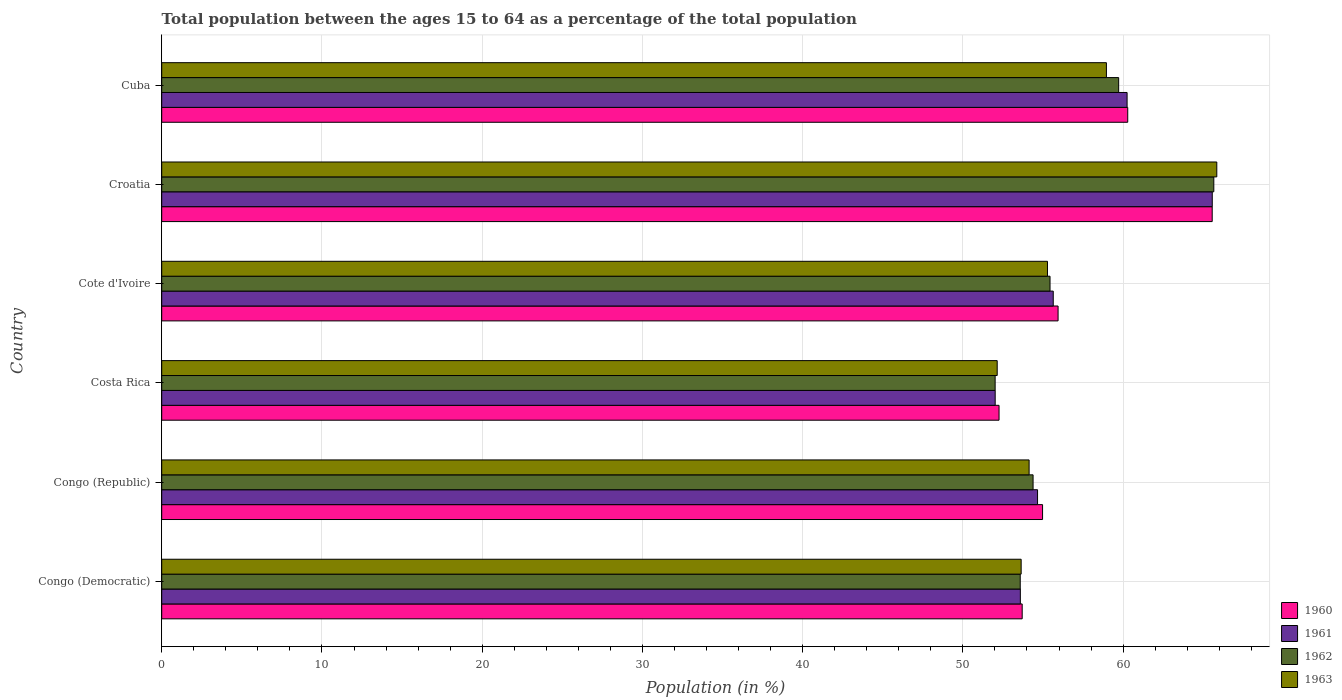Are the number of bars per tick equal to the number of legend labels?
Your answer should be very brief. Yes. How many bars are there on the 6th tick from the top?
Ensure brevity in your answer.  4. What is the label of the 6th group of bars from the top?
Offer a terse response. Congo (Democratic). In how many cases, is the number of bars for a given country not equal to the number of legend labels?
Keep it short and to the point. 0. What is the percentage of the population ages 15 to 64 in 1962 in Cote d'Ivoire?
Offer a very short reply. 55.44. Across all countries, what is the maximum percentage of the population ages 15 to 64 in 1961?
Provide a succinct answer. 65.56. Across all countries, what is the minimum percentage of the population ages 15 to 64 in 1963?
Your answer should be compact. 52.14. In which country was the percentage of the population ages 15 to 64 in 1960 maximum?
Provide a short and direct response. Croatia. What is the total percentage of the population ages 15 to 64 in 1961 in the graph?
Ensure brevity in your answer.  341.71. What is the difference between the percentage of the population ages 15 to 64 in 1962 in Congo (Democratic) and that in Cuba?
Make the answer very short. -6.14. What is the difference between the percentage of the population ages 15 to 64 in 1962 in Congo (Democratic) and the percentage of the population ages 15 to 64 in 1961 in Cuba?
Provide a succinct answer. -6.67. What is the average percentage of the population ages 15 to 64 in 1960 per country?
Your answer should be very brief. 57.12. What is the difference between the percentage of the population ages 15 to 64 in 1963 and percentage of the population ages 15 to 64 in 1961 in Cote d'Ivoire?
Offer a very short reply. -0.36. In how many countries, is the percentage of the population ages 15 to 64 in 1962 greater than 48 ?
Provide a short and direct response. 6. What is the ratio of the percentage of the population ages 15 to 64 in 1963 in Cote d'Ivoire to that in Croatia?
Ensure brevity in your answer.  0.84. Is the percentage of the population ages 15 to 64 in 1960 in Congo (Democratic) less than that in Croatia?
Keep it short and to the point. Yes. What is the difference between the highest and the second highest percentage of the population ages 15 to 64 in 1961?
Offer a terse response. 5.32. What is the difference between the highest and the lowest percentage of the population ages 15 to 64 in 1961?
Offer a terse response. 13.55. In how many countries, is the percentage of the population ages 15 to 64 in 1962 greater than the average percentage of the population ages 15 to 64 in 1962 taken over all countries?
Give a very brief answer. 2. What does the 1st bar from the bottom in Cote d'Ivoire represents?
Keep it short and to the point. 1960. How many bars are there?
Ensure brevity in your answer.  24. Does the graph contain any zero values?
Keep it short and to the point. No. Does the graph contain grids?
Keep it short and to the point. Yes. Where does the legend appear in the graph?
Provide a succinct answer. Bottom right. How are the legend labels stacked?
Your answer should be very brief. Vertical. What is the title of the graph?
Your answer should be compact. Total population between the ages 15 to 64 as a percentage of the total population. What is the label or title of the X-axis?
Your response must be concise. Population (in %). What is the Population (in %) in 1960 in Congo (Democratic)?
Make the answer very short. 53.7. What is the Population (in %) in 1961 in Congo (Democratic)?
Give a very brief answer. 53.59. What is the Population (in %) of 1962 in Congo (Democratic)?
Your response must be concise. 53.58. What is the Population (in %) of 1963 in Congo (Democratic)?
Make the answer very short. 53.64. What is the Population (in %) of 1960 in Congo (Republic)?
Give a very brief answer. 54.97. What is the Population (in %) in 1961 in Congo (Republic)?
Keep it short and to the point. 54.66. What is the Population (in %) in 1962 in Congo (Republic)?
Provide a short and direct response. 54.38. What is the Population (in %) in 1963 in Congo (Republic)?
Offer a very short reply. 54.13. What is the Population (in %) in 1960 in Costa Rica?
Your response must be concise. 52.26. What is the Population (in %) of 1961 in Costa Rica?
Your response must be concise. 52.02. What is the Population (in %) in 1962 in Costa Rica?
Your answer should be very brief. 52.01. What is the Population (in %) in 1963 in Costa Rica?
Keep it short and to the point. 52.14. What is the Population (in %) in 1960 in Cote d'Ivoire?
Your answer should be compact. 55.94. What is the Population (in %) in 1961 in Cote d'Ivoire?
Ensure brevity in your answer.  55.64. What is the Population (in %) in 1962 in Cote d'Ivoire?
Your answer should be very brief. 55.44. What is the Population (in %) of 1963 in Cote d'Ivoire?
Offer a terse response. 55.28. What is the Population (in %) of 1960 in Croatia?
Provide a succinct answer. 65.56. What is the Population (in %) of 1961 in Croatia?
Offer a very short reply. 65.56. What is the Population (in %) in 1962 in Croatia?
Offer a terse response. 65.66. What is the Population (in %) in 1963 in Croatia?
Your response must be concise. 65.85. What is the Population (in %) in 1960 in Cuba?
Keep it short and to the point. 60.29. What is the Population (in %) in 1961 in Cuba?
Your response must be concise. 60.25. What is the Population (in %) of 1962 in Cuba?
Your response must be concise. 59.72. What is the Population (in %) in 1963 in Cuba?
Make the answer very short. 58.96. Across all countries, what is the maximum Population (in %) in 1960?
Your response must be concise. 65.56. Across all countries, what is the maximum Population (in %) of 1961?
Keep it short and to the point. 65.56. Across all countries, what is the maximum Population (in %) in 1962?
Provide a short and direct response. 65.66. Across all countries, what is the maximum Population (in %) in 1963?
Your answer should be compact. 65.85. Across all countries, what is the minimum Population (in %) of 1960?
Provide a succinct answer. 52.26. Across all countries, what is the minimum Population (in %) of 1961?
Your response must be concise. 52.02. Across all countries, what is the minimum Population (in %) of 1962?
Ensure brevity in your answer.  52.01. Across all countries, what is the minimum Population (in %) of 1963?
Your answer should be very brief. 52.14. What is the total Population (in %) in 1960 in the graph?
Offer a terse response. 342.72. What is the total Population (in %) in 1961 in the graph?
Your answer should be compact. 341.71. What is the total Population (in %) of 1962 in the graph?
Give a very brief answer. 340.79. What is the total Population (in %) of 1963 in the graph?
Ensure brevity in your answer.  340. What is the difference between the Population (in %) of 1960 in Congo (Democratic) and that in Congo (Republic)?
Your answer should be compact. -1.27. What is the difference between the Population (in %) of 1961 in Congo (Democratic) and that in Congo (Republic)?
Make the answer very short. -1.07. What is the difference between the Population (in %) of 1962 in Congo (Democratic) and that in Congo (Republic)?
Keep it short and to the point. -0.8. What is the difference between the Population (in %) in 1963 in Congo (Democratic) and that in Congo (Republic)?
Make the answer very short. -0.5. What is the difference between the Population (in %) in 1960 in Congo (Democratic) and that in Costa Rica?
Give a very brief answer. 1.44. What is the difference between the Population (in %) of 1961 in Congo (Democratic) and that in Costa Rica?
Give a very brief answer. 1.57. What is the difference between the Population (in %) of 1962 in Congo (Democratic) and that in Costa Rica?
Offer a very short reply. 1.57. What is the difference between the Population (in %) of 1963 in Congo (Democratic) and that in Costa Rica?
Your answer should be compact. 1.5. What is the difference between the Population (in %) of 1960 in Congo (Democratic) and that in Cote d'Ivoire?
Offer a very short reply. -2.24. What is the difference between the Population (in %) in 1961 in Congo (Democratic) and that in Cote d'Ivoire?
Keep it short and to the point. -2.05. What is the difference between the Population (in %) in 1962 in Congo (Democratic) and that in Cote d'Ivoire?
Give a very brief answer. -1.86. What is the difference between the Population (in %) of 1963 in Congo (Democratic) and that in Cote d'Ivoire?
Provide a short and direct response. -1.64. What is the difference between the Population (in %) of 1960 in Congo (Democratic) and that in Croatia?
Offer a very short reply. -11.86. What is the difference between the Population (in %) in 1961 in Congo (Democratic) and that in Croatia?
Your response must be concise. -11.98. What is the difference between the Population (in %) in 1962 in Congo (Democratic) and that in Croatia?
Offer a very short reply. -12.08. What is the difference between the Population (in %) in 1963 in Congo (Democratic) and that in Croatia?
Offer a very short reply. -12.21. What is the difference between the Population (in %) in 1960 in Congo (Democratic) and that in Cuba?
Offer a very short reply. -6.59. What is the difference between the Population (in %) of 1961 in Congo (Democratic) and that in Cuba?
Provide a short and direct response. -6.66. What is the difference between the Population (in %) of 1962 in Congo (Democratic) and that in Cuba?
Offer a terse response. -6.14. What is the difference between the Population (in %) in 1963 in Congo (Democratic) and that in Cuba?
Provide a succinct answer. -5.32. What is the difference between the Population (in %) of 1960 in Congo (Republic) and that in Costa Rica?
Offer a terse response. 2.72. What is the difference between the Population (in %) of 1961 in Congo (Republic) and that in Costa Rica?
Give a very brief answer. 2.64. What is the difference between the Population (in %) of 1962 in Congo (Republic) and that in Costa Rica?
Offer a very short reply. 2.37. What is the difference between the Population (in %) of 1963 in Congo (Republic) and that in Costa Rica?
Offer a very short reply. 1.99. What is the difference between the Population (in %) in 1960 in Congo (Republic) and that in Cote d'Ivoire?
Your answer should be compact. -0.97. What is the difference between the Population (in %) in 1961 in Congo (Republic) and that in Cote d'Ivoire?
Your answer should be very brief. -0.98. What is the difference between the Population (in %) of 1962 in Congo (Republic) and that in Cote d'Ivoire?
Your answer should be compact. -1.06. What is the difference between the Population (in %) in 1963 in Congo (Republic) and that in Cote d'Ivoire?
Make the answer very short. -1.15. What is the difference between the Population (in %) of 1960 in Congo (Republic) and that in Croatia?
Keep it short and to the point. -10.59. What is the difference between the Population (in %) in 1961 in Congo (Republic) and that in Croatia?
Make the answer very short. -10.9. What is the difference between the Population (in %) in 1962 in Congo (Republic) and that in Croatia?
Your answer should be compact. -11.28. What is the difference between the Population (in %) in 1963 in Congo (Republic) and that in Croatia?
Your response must be concise. -11.71. What is the difference between the Population (in %) of 1960 in Congo (Republic) and that in Cuba?
Provide a short and direct response. -5.32. What is the difference between the Population (in %) in 1961 in Congo (Republic) and that in Cuba?
Keep it short and to the point. -5.59. What is the difference between the Population (in %) in 1962 in Congo (Republic) and that in Cuba?
Offer a very short reply. -5.34. What is the difference between the Population (in %) of 1963 in Congo (Republic) and that in Cuba?
Offer a very short reply. -4.83. What is the difference between the Population (in %) in 1960 in Costa Rica and that in Cote d'Ivoire?
Give a very brief answer. -3.68. What is the difference between the Population (in %) in 1961 in Costa Rica and that in Cote d'Ivoire?
Give a very brief answer. -3.62. What is the difference between the Population (in %) of 1962 in Costa Rica and that in Cote d'Ivoire?
Provide a short and direct response. -3.43. What is the difference between the Population (in %) in 1963 in Costa Rica and that in Cote d'Ivoire?
Offer a terse response. -3.14. What is the difference between the Population (in %) in 1960 in Costa Rica and that in Croatia?
Give a very brief answer. -13.3. What is the difference between the Population (in %) of 1961 in Costa Rica and that in Croatia?
Offer a very short reply. -13.55. What is the difference between the Population (in %) in 1962 in Costa Rica and that in Croatia?
Give a very brief answer. -13.65. What is the difference between the Population (in %) of 1963 in Costa Rica and that in Croatia?
Make the answer very short. -13.71. What is the difference between the Population (in %) in 1960 in Costa Rica and that in Cuba?
Your response must be concise. -8.03. What is the difference between the Population (in %) in 1961 in Costa Rica and that in Cuba?
Provide a short and direct response. -8.23. What is the difference between the Population (in %) in 1962 in Costa Rica and that in Cuba?
Offer a very short reply. -7.71. What is the difference between the Population (in %) in 1963 in Costa Rica and that in Cuba?
Your answer should be compact. -6.82. What is the difference between the Population (in %) in 1960 in Cote d'Ivoire and that in Croatia?
Provide a succinct answer. -9.62. What is the difference between the Population (in %) of 1961 in Cote d'Ivoire and that in Croatia?
Keep it short and to the point. -9.92. What is the difference between the Population (in %) of 1962 in Cote d'Ivoire and that in Croatia?
Your answer should be very brief. -10.22. What is the difference between the Population (in %) in 1963 in Cote d'Ivoire and that in Croatia?
Your answer should be compact. -10.57. What is the difference between the Population (in %) of 1960 in Cote d'Ivoire and that in Cuba?
Make the answer very short. -4.35. What is the difference between the Population (in %) of 1961 in Cote d'Ivoire and that in Cuba?
Ensure brevity in your answer.  -4.61. What is the difference between the Population (in %) in 1962 in Cote d'Ivoire and that in Cuba?
Offer a very short reply. -4.28. What is the difference between the Population (in %) of 1963 in Cote d'Ivoire and that in Cuba?
Ensure brevity in your answer.  -3.68. What is the difference between the Population (in %) of 1960 in Croatia and that in Cuba?
Your answer should be compact. 5.27. What is the difference between the Population (in %) in 1961 in Croatia and that in Cuba?
Ensure brevity in your answer.  5.32. What is the difference between the Population (in %) of 1962 in Croatia and that in Cuba?
Provide a succinct answer. 5.94. What is the difference between the Population (in %) in 1963 in Croatia and that in Cuba?
Give a very brief answer. 6.89. What is the difference between the Population (in %) in 1960 in Congo (Democratic) and the Population (in %) in 1961 in Congo (Republic)?
Your answer should be very brief. -0.96. What is the difference between the Population (in %) of 1960 in Congo (Democratic) and the Population (in %) of 1962 in Congo (Republic)?
Provide a succinct answer. -0.68. What is the difference between the Population (in %) of 1960 in Congo (Democratic) and the Population (in %) of 1963 in Congo (Republic)?
Your answer should be compact. -0.43. What is the difference between the Population (in %) in 1961 in Congo (Democratic) and the Population (in %) in 1962 in Congo (Republic)?
Ensure brevity in your answer.  -0.8. What is the difference between the Population (in %) of 1961 in Congo (Democratic) and the Population (in %) of 1963 in Congo (Republic)?
Provide a succinct answer. -0.55. What is the difference between the Population (in %) of 1962 in Congo (Democratic) and the Population (in %) of 1963 in Congo (Republic)?
Ensure brevity in your answer.  -0.55. What is the difference between the Population (in %) in 1960 in Congo (Democratic) and the Population (in %) in 1961 in Costa Rica?
Your answer should be compact. 1.69. What is the difference between the Population (in %) in 1960 in Congo (Democratic) and the Population (in %) in 1962 in Costa Rica?
Keep it short and to the point. 1.69. What is the difference between the Population (in %) of 1960 in Congo (Democratic) and the Population (in %) of 1963 in Costa Rica?
Keep it short and to the point. 1.56. What is the difference between the Population (in %) of 1961 in Congo (Democratic) and the Population (in %) of 1962 in Costa Rica?
Offer a terse response. 1.57. What is the difference between the Population (in %) of 1961 in Congo (Democratic) and the Population (in %) of 1963 in Costa Rica?
Your answer should be very brief. 1.44. What is the difference between the Population (in %) in 1962 in Congo (Democratic) and the Population (in %) in 1963 in Costa Rica?
Offer a very short reply. 1.44. What is the difference between the Population (in %) of 1960 in Congo (Democratic) and the Population (in %) of 1961 in Cote d'Ivoire?
Keep it short and to the point. -1.94. What is the difference between the Population (in %) of 1960 in Congo (Democratic) and the Population (in %) of 1962 in Cote d'Ivoire?
Make the answer very short. -1.74. What is the difference between the Population (in %) of 1960 in Congo (Democratic) and the Population (in %) of 1963 in Cote d'Ivoire?
Offer a terse response. -1.58. What is the difference between the Population (in %) of 1961 in Congo (Democratic) and the Population (in %) of 1962 in Cote d'Ivoire?
Offer a very short reply. -1.85. What is the difference between the Population (in %) in 1961 in Congo (Democratic) and the Population (in %) in 1963 in Cote d'Ivoire?
Your answer should be very brief. -1.69. What is the difference between the Population (in %) of 1962 in Congo (Democratic) and the Population (in %) of 1963 in Cote d'Ivoire?
Provide a succinct answer. -1.7. What is the difference between the Population (in %) of 1960 in Congo (Democratic) and the Population (in %) of 1961 in Croatia?
Ensure brevity in your answer.  -11.86. What is the difference between the Population (in %) in 1960 in Congo (Democratic) and the Population (in %) in 1962 in Croatia?
Keep it short and to the point. -11.96. What is the difference between the Population (in %) of 1960 in Congo (Democratic) and the Population (in %) of 1963 in Croatia?
Your answer should be very brief. -12.15. What is the difference between the Population (in %) of 1961 in Congo (Democratic) and the Population (in %) of 1962 in Croatia?
Provide a short and direct response. -12.07. What is the difference between the Population (in %) of 1961 in Congo (Democratic) and the Population (in %) of 1963 in Croatia?
Provide a succinct answer. -12.26. What is the difference between the Population (in %) of 1962 in Congo (Democratic) and the Population (in %) of 1963 in Croatia?
Make the answer very short. -12.27. What is the difference between the Population (in %) in 1960 in Congo (Democratic) and the Population (in %) in 1961 in Cuba?
Your response must be concise. -6.55. What is the difference between the Population (in %) in 1960 in Congo (Democratic) and the Population (in %) in 1962 in Cuba?
Offer a terse response. -6.02. What is the difference between the Population (in %) in 1960 in Congo (Democratic) and the Population (in %) in 1963 in Cuba?
Offer a very short reply. -5.26. What is the difference between the Population (in %) in 1961 in Congo (Democratic) and the Population (in %) in 1962 in Cuba?
Make the answer very short. -6.14. What is the difference between the Population (in %) of 1961 in Congo (Democratic) and the Population (in %) of 1963 in Cuba?
Ensure brevity in your answer.  -5.37. What is the difference between the Population (in %) in 1962 in Congo (Democratic) and the Population (in %) in 1963 in Cuba?
Your answer should be very brief. -5.38. What is the difference between the Population (in %) of 1960 in Congo (Republic) and the Population (in %) of 1961 in Costa Rica?
Offer a very short reply. 2.96. What is the difference between the Population (in %) of 1960 in Congo (Republic) and the Population (in %) of 1962 in Costa Rica?
Ensure brevity in your answer.  2.96. What is the difference between the Population (in %) of 1960 in Congo (Republic) and the Population (in %) of 1963 in Costa Rica?
Provide a succinct answer. 2.83. What is the difference between the Population (in %) of 1961 in Congo (Republic) and the Population (in %) of 1962 in Costa Rica?
Ensure brevity in your answer.  2.65. What is the difference between the Population (in %) in 1961 in Congo (Republic) and the Population (in %) in 1963 in Costa Rica?
Give a very brief answer. 2.52. What is the difference between the Population (in %) of 1962 in Congo (Republic) and the Population (in %) of 1963 in Costa Rica?
Offer a terse response. 2.24. What is the difference between the Population (in %) in 1960 in Congo (Republic) and the Population (in %) in 1961 in Cote d'Ivoire?
Make the answer very short. -0.67. What is the difference between the Population (in %) in 1960 in Congo (Republic) and the Population (in %) in 1962 in Cote d'Ivoire?
Keep it short and to the point. -0.47. What is the difference between the Population (in %) of 1960 in Congo (Republic) and the Population (in %) of 1963 in Cote d'Ivoire?
Offer a very short reply. -0.31. What is the difference between the Population (in %) in 1961 in Congo (Republic) and the Population (in %) in 1962 in Cote d'Ivoire?
Ensure brevity in your answer.  -0.78. What is the difference between the Population (in %) of 1961 in Congo (Republic) and the Population (in %) of 1963 in Cote d'Ivoire?
Keep it short and to the point. -0.62. What is the difference between the Population (in %) of 1962 in Congo (Republic) and the Population (in %) of 1963 in Cote d'Ivoire?
Provide a short and direct response. -0.9. What is the difference between the Population (in %) of 1960 in Congo (Republic) and the Population (in %) of 1961 in Croatia?
Ensure brevity in your answer.  -10.59. What is the difference between the Population (in %) of 1960 in Congo (Republic) and the Population (in %) of 1962 in Croatia?
Provide a short and direct response. -10.69. What is the difference between the Population (in %) of 1960 in Congo (Republic) and the Population (in %) of 1963 in Croatia?
Make the answer very short. -10.87. What is the difference between the Population (in %) of 1961 in Congo (Republic) and the Population (in %) of 1962 in Croatia?
Keep it short and to the point. -11. What is the difference between the Population (in %) of 1961 in Congo (Republic) and the Population (in %) of 1963 in Croatia?
Your answer should be very brief. -11.19. What is the difference between the Population (in %) in 1962 in Congo (Republic) and the Population (in %) in 1963 in Croatia?
Your answer should be compact. -11.47. What is the difference between the Population (in %) of 1960 in Congo (Republic) and the Population (in %) of 1961 in Cuba?
Provide a succinct answer. -5.28. What is the difference between the Population (in %) of 1960 in Congo (Republic) and the Population (in %) of 1962 in Cuba?
Your answer should be very brief. -4.75. What is the difference between the Population (in %) of 1960 in Congo (Republic) and the Population (in %) of 1963 in Cuba?
Your response must be concise. -3.99. What is the difference between the Population (in %) in 1961 in Congo (Republic) and the Population (in %) in 1962 in Cuba?
Ensure brevity in your answer.  -5.06. What is the difference between the Population (in %) of 1961 in Congo (Republic) and the Population (in %) of 1963 in Cuba?
Ensure brevity in your answer.  -4.3. What is the difference between the Population (in %) of 1962 in Congo (Republic) and the Population (in %) of 1963 in Cuba?
Your answer should be compact. -4.58. What is the difference between the Population (in %) of 1960 in Costa Rica and the Population (in %) of 1961 in Cote d'Ivoire?
Your answer should be very brief. -3.38. What is the difference between the Population (in %) of 1960 in Costa Rica and the Population (in %) of 1962 in Cote d'Ivoire?
Offer a terse response. -3.18. What is the difference between the Population (in %) of 1960 in Costa Rica and the Population (in %) of 1963 in Cote d'Ivoire?
Make the answer very short. -3.02. What is the difference between the Population (in %) of 1961 in Costa Rica and the Population (in %) of 1962 in Cote d'Ivoire?
Provide a succinct answer. -3.42. What is the difference between the Population (in %) in 1961 in Costa Rica and the Population (in %) in 1963 in Cote d'Ivoire?
Your response must be concise. -3.26. What is the difference between the Population (in %) of 1962 in Costa Rica and the Population (in %) of 1963 in Cote d'Ivoire?
Ensure brevity in your answer.  -3.27. What is the difference between the Population (in %) in 1960 in Costa Rica and the Population (in %) in 1961 in Croatia?
Your response must be concise. -13.31. What is the difference between the Population (in %) of 1960 in Costa Rica and the Population (in %) of 1962 in Croatia?
Provide a succinct answer. -13.4. What is the difference between the Population (in %) of 1960 in Costa Rica and the Population (in %) of 1963 in Croatia?
Provide a succinct answer. -13.59. What is the difference between the Population (in %) of 1961 in Costa Rica and the Population (in %) of 1962 in Croatia?
Keep it short and to the point. -13.64. What is the difference between the Population (in %) of 1961 in Costa Rica and the Population (in %) of 1963 in Croatia?
Offer a terse response. -13.83. What is the difference between the Population (in %) of 1962 in Costa Rica and the Population (in %) of 1963 in Croatia?
Offer a very short reply. -13.83. What is the difference between the Population (in %) of 1960 in Costa Rica and the Population (in %) of 1961 in Cuba?
Your answer should be compact. -7.99. What is the difference between the Population (in %) in 1960 in Costa Rica and the Population (in %) in 1962 in Cuba?
Provide a succinct answer. -7.46. What is the difference between the Population (in %) of 1960 in Costa Rica and the Population (in %) of 1963 in Cuba?
Offer a very short reply. -6.7. What is the difference between the Population (in %) of 1961 in Costa Rica and the Population (in %) of 1962 in Cuba?
Offer a very short reply. -7.71. What is the difference between the Population (in %) of 1961 in Costa Rica and the Population (in %) of 1963 in Cuba?
Give a very brief answer. -6.94. What is the difference between the Population (in %) of 1962 in Costa Rica and the Population (in %) of 1963 in Cuba?
Keep it short and to the point. -6.95. What is the difference between the Population (in %) of 1960 in Cote d'Ivoire and the Population (in %) of 1961 in Croatia?
Give a very brief answer. -9.62. What is the difference between the Population (in %) of 1960 in Cote d'Ivoire and the Population (in %) of 1962 in Croatia?
Your response must be concise. -9.72. What is the difference between the Population (in %) of 1960 in Cote d'Ivoire and the Population (in %) of 1963 in Croatia?
Provide a short and direct response. -9.91. What is the difference between the Population (in %) of 1961 in Cote d'Ivoire and the Population (in %) of 1962 in Croatia?
Offer a very short reply. -10.02. What is the difference between the Population (in %) in 1961 in Cote d'Ivoire and the Population (in %) in 1963 in Croatia?
Give a very brief answer. -10.21. What is the difference between the Population (in %) of 1962 in Cote d'Ivoire and the Population (in %) of 1963 in Croatia?
Make the answer very short. -10.41. What is the difference between the Population (in %) of 1960 in Cote d'Ivoire and the Population (in %) of 1961 in Cuba?
Ensure brevity in your answer.  -4.31. What is the difference between the Population (in %) of 1960 in Cote d'Ivoire and the Population (in %) of 1962 in Cuba?
Your answer should be compact. -3.78. What is the difference between the Population (in %) of 1960 in Cote d'Ivoire and the Population (in %) of 1963 in Cuba?
Offer a very short reply. -3.02. What is the difference between the Population (in %) in 1961 in Cote d'Ivoire and the Population (in %) in 1962 in Cuba?
Offer a terse response. -4.08. What is the difference between the Population (in %) in 1961 in Cote d'Ivoire and the Population (in %) in 1963 in Cuba?
Give a very brief answer. -3.32. What is the difference between the Population (in %) of 1962 in Cote d'Ivoire and the Population (in %) of 1963 in Cuba?
Your response must be concise. -3.52. What is the difference between the Population (in %) in 1960 in Croatia and the Population (in %) in 1961 in Cuba?
Provide a short and direct response. 5.31. What is the difference between the Population (in %) in 1960 in Croatia and the Population (in %) in 1962 in Cuba?
Provide a succinct answer. 5.84. What is the difference between the Population (in %) of 1960 in Croatia and the Population (in %) of 1963 in Cuba?
Provide a succinct answer. 6.6. What is the difference between the Population (in %) of 1961 in Croatia and the Population (in %) of 1962 in Cuba?
Provide a short and direct response. 5.84. What is the difference between the Population (in %) in 1961 in Croatia and the Population (in %) in 1963 in Cuba?
Your answer should be compact. 6.61. What is the difference between the Population (in %) of 1962 in Croatia and the Population (in %) of 1963 in Cuba?
Provide a succinct answer. 6.7. What is the average Population (in %) of 1960 per country?
Your answer should be compact. 57.12. What is the average Population (in %) in 1961 per country?
Give a very brief answer. 56.95. What is the average Population (in %) in 1962 per country?
Make the answer very short. 56.8. What is the average Population (in %) of 1963 per country?
Your response must be concise. 56.67. What is the difference between the Population (in %) in 1960 and Population (in %) in 1961 in Congo (Democratic)?
Keep it short and to the point. 0.12. What is the difference between the Population (in %) in 1960 and Population (in %) in 1962 in Congo (Democratic)?
Offer a very short reply. 0.12. What is the difference between the Population (in %) of 1960 and Population (in %) of 1963 in Congo (Democratic)?
Provide a succinct answer. 0.06. What is the difference between the Population (in %) of 1961 and Population (in %) of 1962 in Congo (Democratic)?
Provide a short and direct response. 0.01. What is the difference between the Population (in %) in 1961 and Population (in %) in 1963 in Congo (Democratic)?
Keep it short and to the point. -0.05. What is the difference between the Population (in %) of 1962 and Population (in %) of 1963 in Congo (Democratic)?
Offer a very short reply. -0.06. What is the difference between the Population (in %) in 1960 and Population (in %) in 1961 in Congo (Republic)?
Offer a terse response. 0.31. What is the difference between the Population (in %) in 1960 and Population (in %) in 1962 in Congo (Republic)?
Give a very brief answer. 0.59. What is the difference between the Population (in %) of 1960 and Population (in %) of 1963 in Congo (Republic)?
Make the answer very short. 0.84. What is the difference between the Population (in %) of 1961 and Population (in %) of 1962 in Congo (Republic)?
Keep it short and to the point. 0.28. What is the difference between the Population (in %) of 1961 and Population (in %) of 1963 in Congo (Republic)?
Give a very brief answer. 0.53. What is the difference between the Population (in %) of 1962 and Population (in %) of 1963 in Congo (Republic)?
Provide a succinct answer. 0.25. What is the difference between the Population (in %) in 1960 and Population (in %) in 1961 in Costa Rica?
Give a very brief answer. 0.24. What is the difference between the Population (in %) of 1960 and Population (in %) of 1962 in Costa Rica?
Make the answer very short. 0.24. What is the difference between the Population (in %) in 1960 and Population (in %) in 1963 in Costa Rica?
Provide a succinct answer. 0.12. What is the difference between the Population (in %) in 1961 and Population (in %) in 1962 in Costa Rica?
Keep it short and to the point. 0. What is the difference between the Population (in %) of 1961 and Population (in %) of 1963 in Costa Rica?
Give a very brief answer. -0.12. What is the difference between the Population (in %) of 1962 and Population (in %) of 1963 in Costa Rica?
Give a very brief answer. -0.13. What is the difference between the Population (in %) in 1960 and Population (in %) in 1961 in Cote d'Ivoire?
Provide a short and direct response. 0.3. What is the difference between the Population (in %) in 1960 and Population (in %) in 1962 in Cote d'Ivoire?
Provide a short and direct response. 0.5. What is the difference between the Population (in %) of 1960 and Population (in %) of 1963 in Cote d'Ivoire?
Give a very brief answer. 0.66. What is the difference between the Population (in %) of 1961 and Population (in %) of 1962 in Cote d'Ivoire?
Your answer should be very brief. 0.2. What is the difference between the Population (in %) in 1961 and Population (in %) in 1963 in Cote d'Ivoire?
Provide a short and direct response. 0.36. What is the difference between the Population (in %) in 1962 and Population (in %) in 1963 in Cote d'Ivoire?
Your answer should be compact. 0.16. What is the difference between the Population (in %) of 1960 and Population (in %) of 1961 in Croatia?
Give a very brief answer. -0. What is the difference between the Population (in %) of 1960 and Population (in %) of 1962 in Croatia?
Make the answer very short. -0.1. What is the difference between the Population (in %) of 1960 and Population (in %) of 1963 in Croatia?
Provide a succinct answer. -0.29. What is the difference between the Population (in %) in 1961 and Population (in %) in 1962 in Croatia?
Your response must be concise. -0.1. What is the difference between the Population (in %) in 1961 and Population (in %) in 1963 in Croatia?
Give a very brief answer. -0.28. What is the difference between the Population (in %) in 1962 and Population (in %) in 1963 in Croatia?
Provide a short and direct response. -0.19. What is the difference between the Population (in %) of 1960 and Population (in %) of 1961 in Cuba?
Your response must be concise. 0.04. What is the difference between the Population (in %) in 1960 and Population (in %) in 1962 in Cuba?
Ensure brevity in your answer.  0.57. What is the difference between the Population (in %) of 1960 and Population (in %) of 1963 in Cuba?
Ensure brevity in your answer.  1.33. What is the difference between the Population (in %) of 1961 and Population (in %) of 1962 in Cuba?
Your response must be concise. 0.53. What is the difference between the Population (in %) of 1961 and Population (in %) of 1963 in Cuba?
Keep it short and to the point. 1.29. What is the difference between the Population (in %) in 1962 and Population (in %) in 1963 in Cuba?
Give a very brief answer. 0.76. What is the ratio of the Population (in %) in 1960 in Congo (Democratic) to that in Congo (Republic)?
Make the answer very short. 0.98. What is the ratio of the Population (in %) of 1961 in Congo (Democratic) to that in Congo (Republic)?
Make the answer very short. 0.98. What is the ratio of the Population (in %) of 1963 in Congo (Democratic) to that in Congo (Republic)?
Keep it short and to the point. 0.99. What is the ratio of the Population (in %) of 1960 in Congo (Democratic) to that in Costa Rica?
Offer a terse response. 1.03. What is the ratio of the Population (in %) in 1961 in Congo (Democratic) to that in Costa Rica?
Ensure brevity in your answer.  1.03. What is the ratio of the Population (in %) in 1962 in Congo (Democratic) to that in Costa Rica?
Your response must be concise. 1.03. What is the ratio of the Population (in %) of 1963 in Congo (Democratic) to that in Costa Rica?
Keep it short and to the point. 1.03. What is the ratio of the Population (in %) of 1961 in Congo (Democratic) to that in Cote d'Ivoire?
Offer a very short reply. 0.96. What is the ratio of the Population (in %) in 1962 in Congo (Democratic) to that in Cote d'Ivoire?
Ensure brevity in your answer.  0.97. What is the ratio of the Population (in %) in 1963 in Congo (Democratic) to that in Cote d'Ivoire?
Your response must be concise. 0.97. What is the ratio of the Population (in %) of 1960 in Congo (Democratic) to that in Croatia?
Offer a very short reply. 0.82. What is the ratio of the Population (in %) of 1961 in Congo (Democratic) to that in Croatia?
Give a very brief answer. 0.82. What is the ratio of the Population (in %) of 1962 in Congo (Democratic) to that in Croatia?
Your answer should be compact. 0.82. What is the ratio of the Population (in %) of 1963 in Congo (Democratic) to that in Croatia?
Make the answer very short. 0.81. What is the ratio of the Population (in %) in 1960 in Congo (Democratic) to that in Cuba?
Give a very brief answer. 0.89. What is the ratio of the Population (in %) in 1961 in Congo (Democratic) to that in Cuba?
Ensure brevity in your answer.  0.89. What is the ratio of the Population (in %) of 1962 in Congo (Democratic) to that in Cuba?
Your answer should be very brief. 0.9. What is the ratio of the Population (in %) of 1963 in Congo (Democratic) to that in Cuba?
Your response must be concise. 0.91. What is the ratio of the Population (in %) in 1960 in Congo (Republic) to that in Costa Rica?
Offer a very short reply. 1.05. What is the ratio of the Population (in %) of 1961 in Congo (Republic) to that in Costa Rica?
Your answer should be compact. 1.05. What is the ratio of the Population (in %) of 1962 in Congo (Republic) to that in Costa Rica?
Offer a terse response. 1.05. What is the ratio of the Population (in %) of 1963 in Congo (Republic) to that in Costa Rica?
Your answer should be compact. 1.04. What is the ratio of the Population (in %) in 1960 in Congo (Republic) to that in Cote d'Ivoire?
Provide a short and direct response. 0.98. What is the ratio of the Population (in %) of 1961 in Congo (Republic) to that in Cote d'Ivoire?
Keep it short and to the point. 0.98. What is the ratio of the Population (in %) of 1962 in Congo (Republic) to that in Cote d'Ivoire?
Offer a terse response. 0.98. What is the ratio of the Population (in %) in 1963 in Congo (Republic) to that in Cote d'Ivoire?
Give a very brief answer. 0.98. What is the ratio of the Population (in %) in 1960 in Congo (Republic) to that in Croatia?
Make the answer very short. 0.84. What is the ratio of the Population (in %) in 1961 in Congo (Republic) to that in Croatia?
Ensure brevity in your answer.  0.83. What is the ratio of the Population (in %) of 1962 in Congo (Republic) to that in Croatia?
Give a very brief answer. 0.83. What is the ratio of the Population (in %) of 1963 in Congo (Republic) to that in Croatia?
Give a very brief answer. 0.82. What is the ratio of the Population (in %) of 1960 in Congo (Republic) to that in Cuba?
Provide a short and direct response. 0.91. What is the ratio of the Population (in %) in 1961 in Congo (Republic) to that in Cuba?
Offer a terse response. 0.91. What is the ratio of the Population (in %) in 1962 in Congo (Republic) to that in Cuba?
Provide a short and direct response. 0.91. What is the ratio of the Population (in %) in 1963 in Congo (Republic) to that in Cuba?
Make the answer very short. 0.92. What is the ratio of the Population (in %) in 1960 in Costa Rica to that in Cote d'Ivoire?
Keep it short and to the point. 0.93. What is the ratio of the Population (in %) of 1961 in Costa Rica to that in Cote d'Ivoire?
Give a very brief answer. 0.93. What is the ratio of the Population (in %) of 1962 in Costa Rica to that in Cote d'Ivoire?
Your answer should be compact. 0.94. What is the ratio of the Population (in %) in 1963 in Costa Rica to that in Cote d'Ivoire?
Give a very brief answer. 0.94. What is the ratio of the Population (in %) of 1960 in Costa Rica to that in Croatia?
Provide a short and direct response. 0.8. What is the ratio of the Population (in %) of 1961 in Costa Rica to that in Croatia?
Your answer should be very brief. 0.79. What is the ratio of the Population (in %) of 1962 in Costa Rica to that in Croatia?
Give a very brief answer. 0.79. What is the ratio of the Population (in %) of 1963 in Costa Rica to that in Croatia?
Provide a short and direct response. 0.79. What is the ratio of the Population (in %) of 1960 in Costa Rica to that in Cuba?
Your response must be concise. 0.87. What is the ratio of the Population (in %) in 1961 in Costa Rica to that in Cuba?
Offer a terse response. 0.86. What is the ratio of the Population (in %) of 1962 in Costa Rica to that in Cuba?
Give a very brief answer. 0.87. What is the ratio of the Population (in %) in 1963 in Costa Rica to that in Cuba?
Your answer should be compact. 0.88. What is the ratio of the Population (in %) in 1960 in Cote d'Ivoire to that in Croatia?
Keep it short and to the point. 0.85. What is the ratio of the Population (in %) in 1961 in Cote d'Ivoire to that in Croatia?
Ensure brevity in your answer.  0.85. What is the ratio of the Population (in %) of 1962 in Cote d'Ivoire to that in Croatia?
Your answer should be compact. 0.84. What is the ratio of the Population (in %) in 1963 in Cote d'Ivoire to that in Croatia?
Ensure brevity in your answer.  0.84. What is the ratio of the Population (in %) in 1960 in Cote d'Ivoire to that in Cuba?
Provide a short and direct response. 0.93. What is the ratio of the Population (in %) of 1961 in Cote d'Ivoire to that in Cuba?
Keep it short and to the point. 0.92. What is the ratio of the Population (in %) in 1962 in Cote d'Ivoire to that in Cuba?
Your answer should be very brief. 0.93. What is the ratio of the Population (in %) of 1963 in Cote d'Ivoire to that in Cuba?
Offer a very short reply. 0.94. What is the ratio of the Population (in %) of 1960 in Croatia to that in Cuba?
Your response must be concise. 1.09. What is the ratio of the Population (in %) of 1961 in Croatia to that in Cuba?
Offer a very short reply. 1.09. What is the ratio of the Population (in %) of 1962 in Croatia to that in Cuba?
Ensure brevity in your answer.  1.1. What is the ratio of the Population (in %) of 1963 in Croatia to that in Cuba?
Offer a very short reply. 1.12. What is the difference between the highest and the second highest Population (in %) in 1960?
Make the answer very short. 5.27. What is the difference between the highest and the second highest Population (in %) in 1961?
Keep it short and to the point. 5.32. What is the difference between the highest and the second highest Population (in %) in 1962?
Give a very brief answer. 5.94. What is the difference between the highest and the second highest Population (in %) of 1963?
Your response must be concise. 6.89. What is the difference between the highest and the lowest Population (in %) in 1960?
Make the answer very short. 13.3. What is the difference between the highest and the lowest Population (in %) of 1961?
Make the answer very short. 13.55. What is the difference between the highest and the lowest Population (in %) of 1962?
Provide a succinct answer. 13.65. What is the difference between the highest and the lowest Population (in %) in 1963?
Provide a short and direct response. 13.71. 